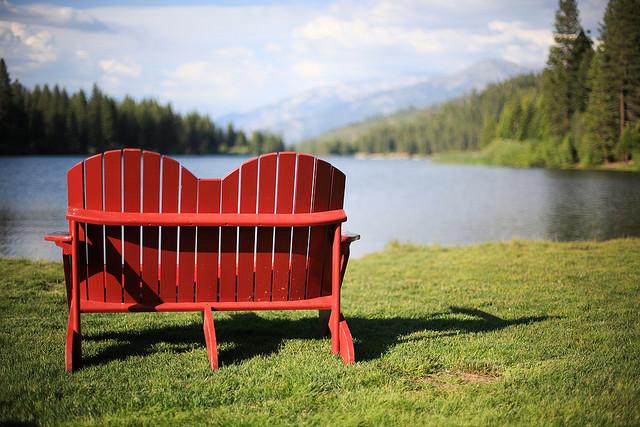What is the color of the bench facing the lake?
Quick response, please. Red. Is this the ocean?
Answer briefly. No. How many people would fit on this bench?
Give a very brief answer. 2. 